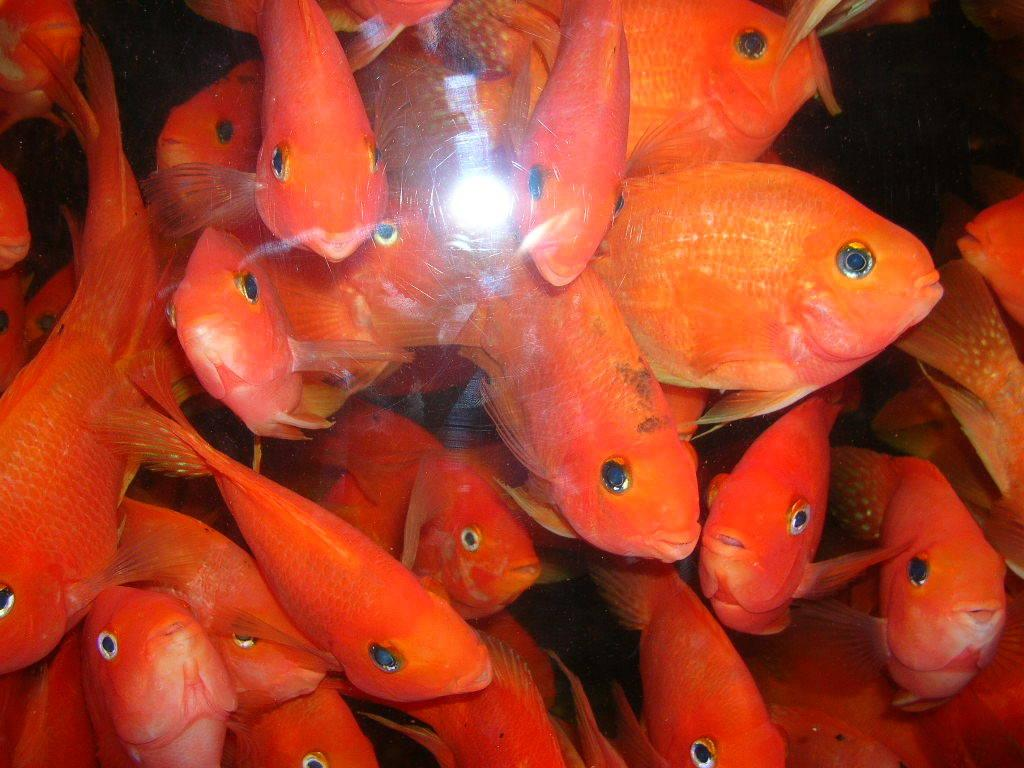What is the main subject of the image? The main subject of the image is a group of fishes. Can you describe the background of the image? The background of the image is dark. What type of throat problem do the fishes have in the image? There is no indication of any throat problems in the image; it features a group of fishes in a dark background. What degree of difficulty do the fishes face in the image? There is no indication of any difficulty faced by the fishes in the image; they are simply swimming in a dark background. 